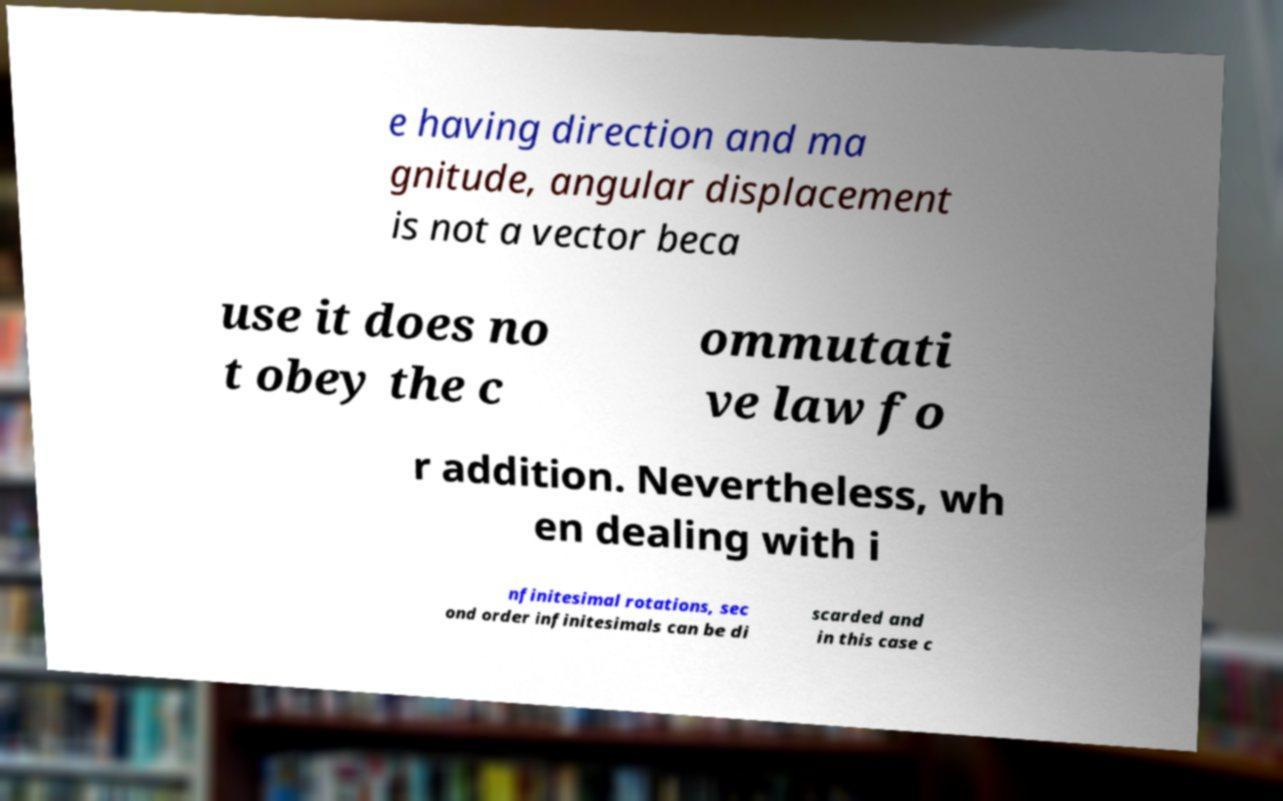What messages or text are displayed in this image? I need them in a readable, typed format. e having direction and ma gnitude, angular displacement is not a vector beca use it does no t obey the c ommutati ve law fo r addition. Nevertheless, wh en dealing with i nfinitesimal rotations, sec ond order infinitesimals can be di scarded and in this case c 